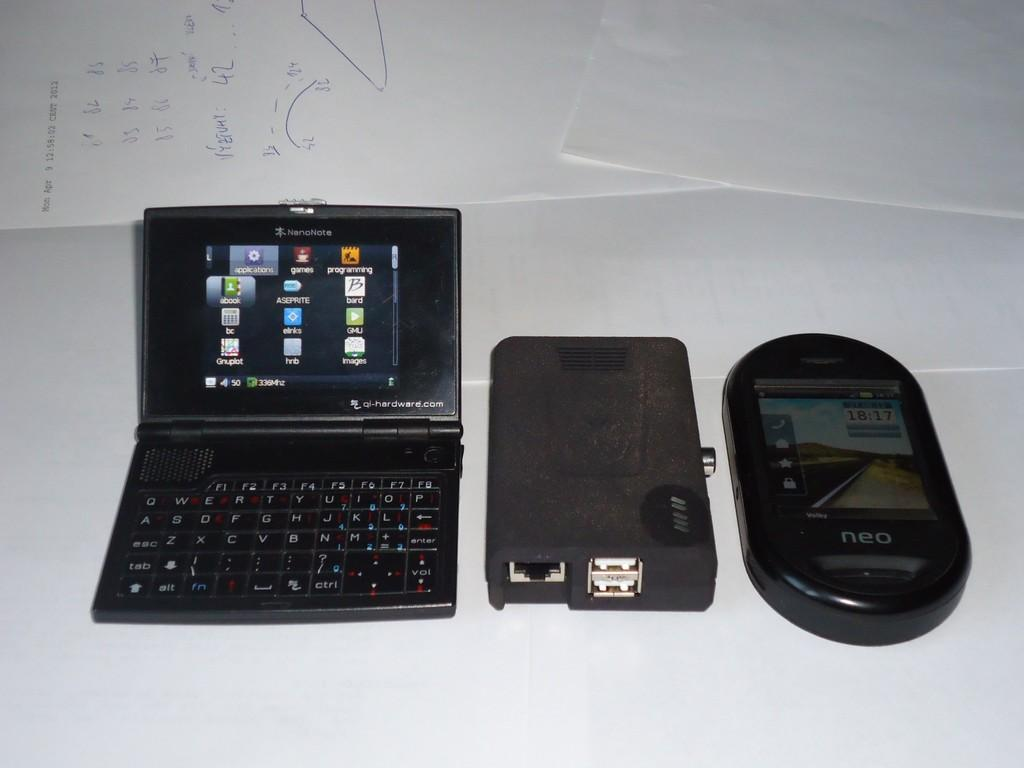<image>
Write a terse but informative summary of the picture. A Neo phone is the third electronics gadget on a white surface. 